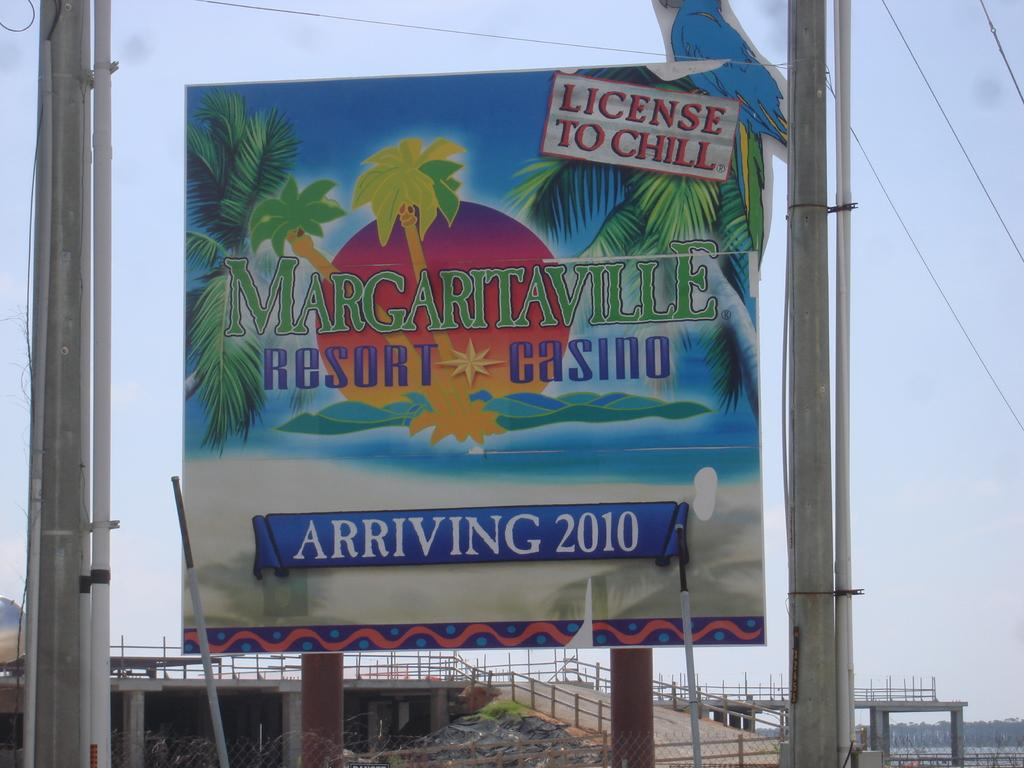What is the main object in the image? There is a board in the image. What is on the board? Something is written on the board. What other objects can be seen in the image? There are poles and a bridge-like structure with fencing in the image. What is the emotional state of the cows in the image? There are no cows present in the image, so their emotional state cannot be determined. 